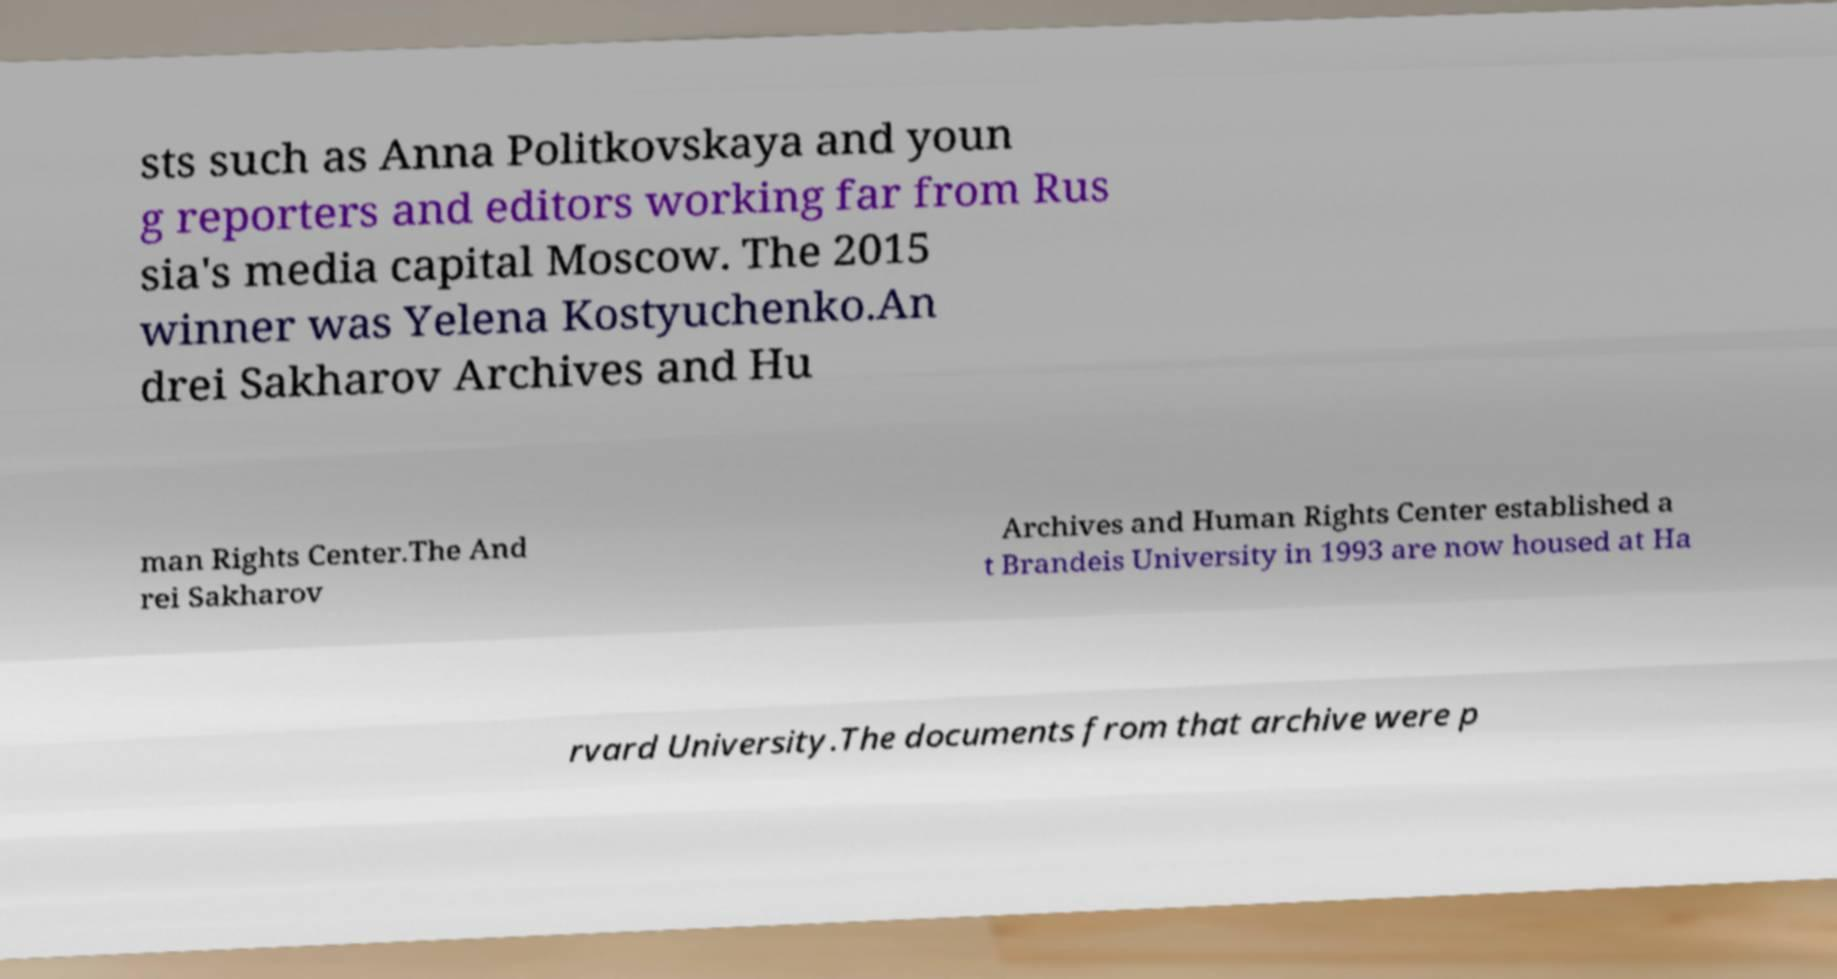Could you extract and type out the text from this image? sts such as Anna Politkovskaya and youn g reporters and editors working far from Rus sia's media capital Moscow. The 2015 winner was Yelena Kostyuchenko.An drei Sakharov Archives and Hu man Rights Center.The And rei Sakharov Archives and Human Rights Center established a t Brandeis University in 1993 are now housed at Ha rvard University.The documents from that archive were p 